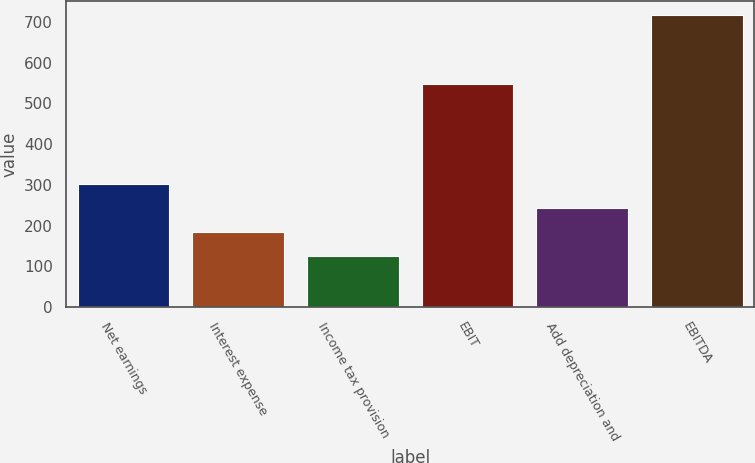<chart> <loc_0><loc_0><loc_500><loc_500><bar_chart><fcel>Net earnings<fcel>Interest expense<fcel>Income tax provision<fcel>EBIT<fcel>Add depreciation and<fcel>EBITDA<nl><fcel>303.03<fcel>185.01<fcel>126<fcel>548.1<fcel>244.02<fcel>716.1<nl></chart> 